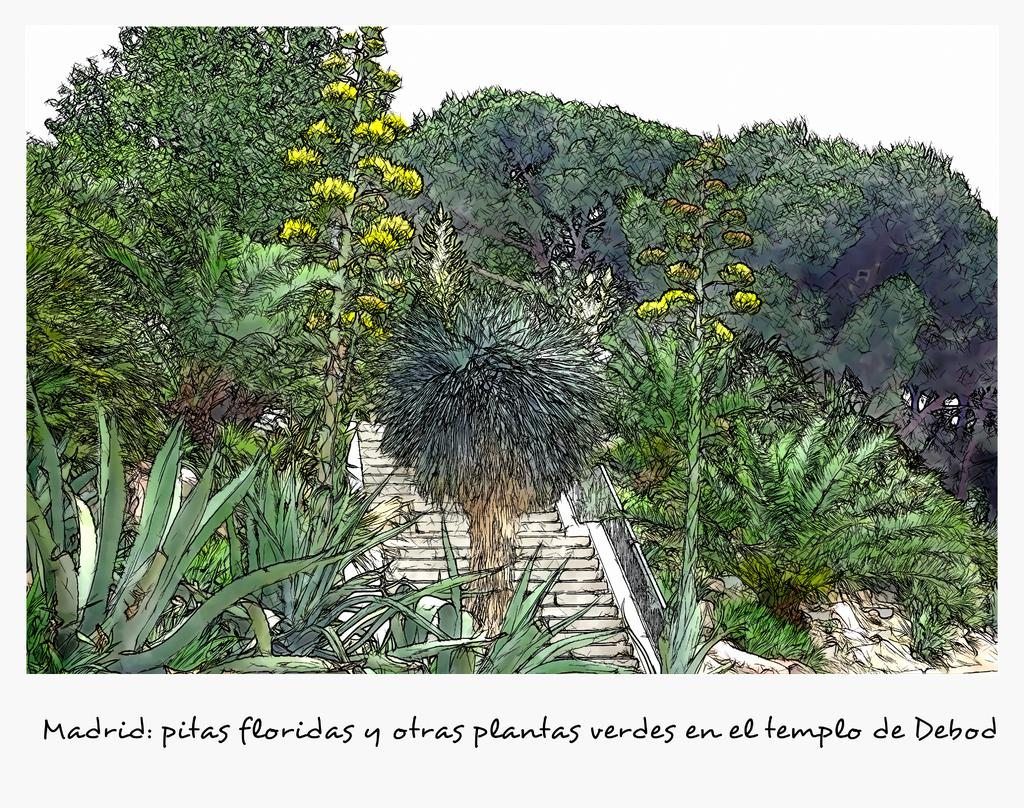What is shown in the image that represents natural elements? There is a depiction of trees in the image. What architectural feature is located in the center of the image? There are stairs in the center of the image. Where can text be found in the image? Text is written on the bottom side of the image. How many rings are visible on the trees in the image? There are no rings visible on the trees in the image, as it is a depiction of trees rather than a photograph of actual trees. What division is responsible for maintaining the stairs in the image? There is no information provided about any divisions responsible for maintaining the stairs in the image. 